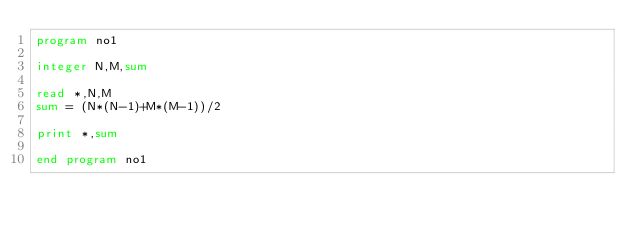Convert code to text. <code><loc_0><loc_0><loc_500><loc_500><_FORTRAN_>program no1

integer N,M,sum

read *,N,M
sum = (N*(N-1)+M*(M-1))/2

print *,sum

end program no1</code> 